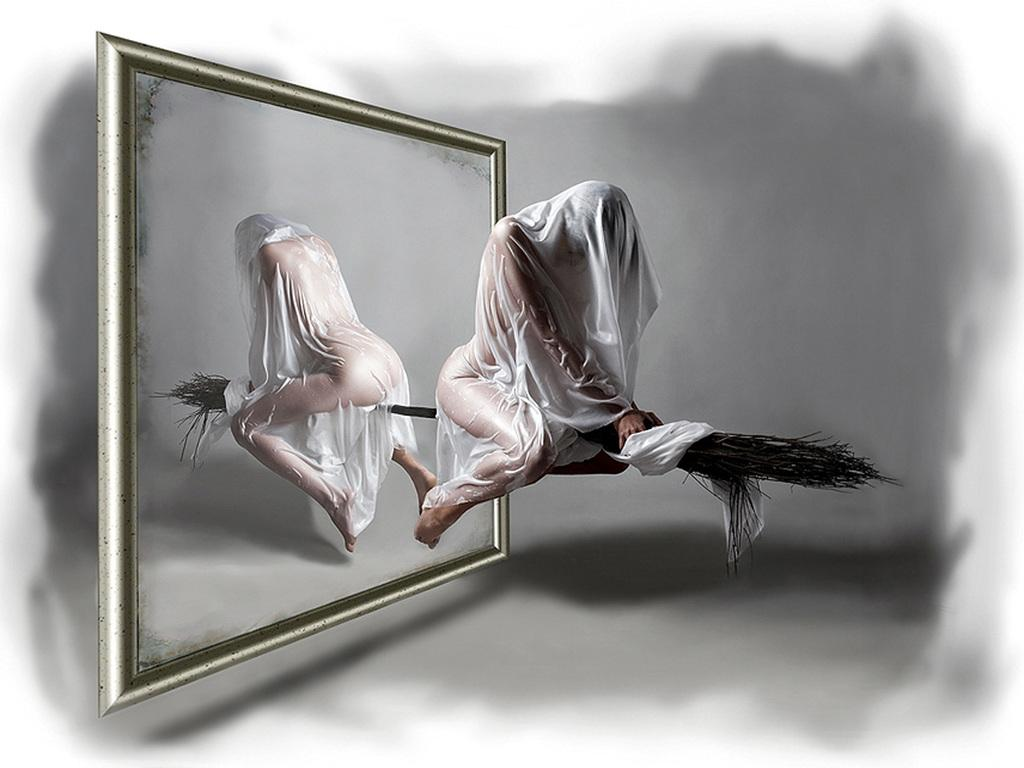Who or what is the main subject in the image? There is a person in the image. What is the person doing in the image? The person is sitting on a broomstick. What is the person wearing in the image? The person is wearing white clothing. What can be seen in the background of the image? There is a background in the image, and a frame is visible in the background. How many brushes are being used by the person in the image? There are no brushes visible in the image; the person is sitting on a broomstick. What type of cart is being pulled by the person in the image? There is no cart present in the image; the person is sitting on a broomstick. 